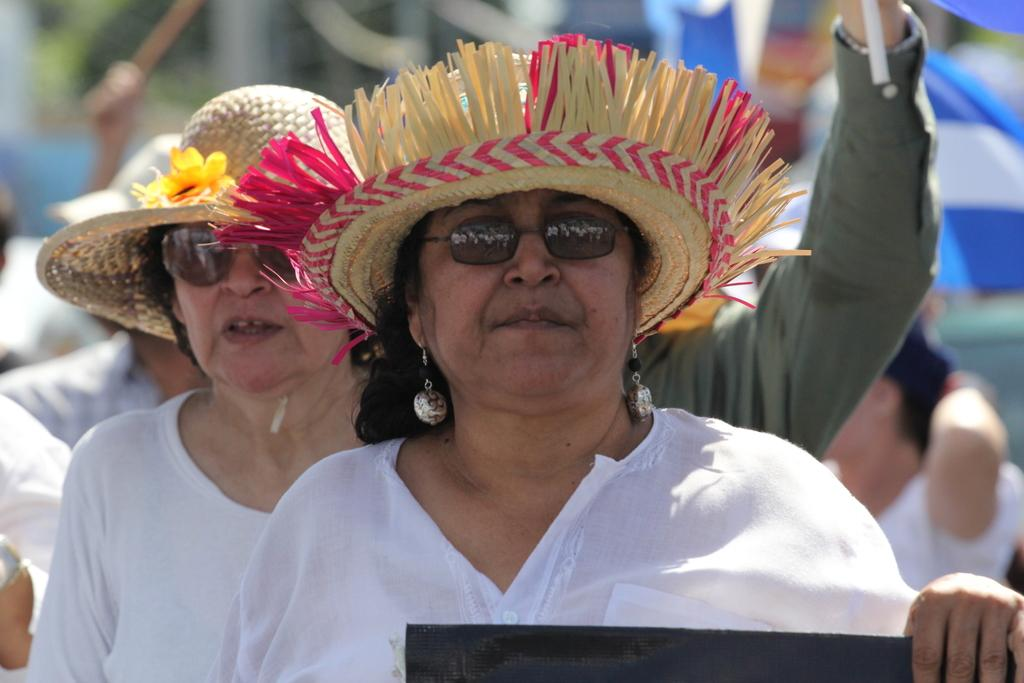How many people are present in the image? The number of people present in the image cannot be determined from the provided fact. What type of eggnog is being served to the people in the image? There is no eggnog present in the image, as the provided fact only mentions that there are people in the image. 